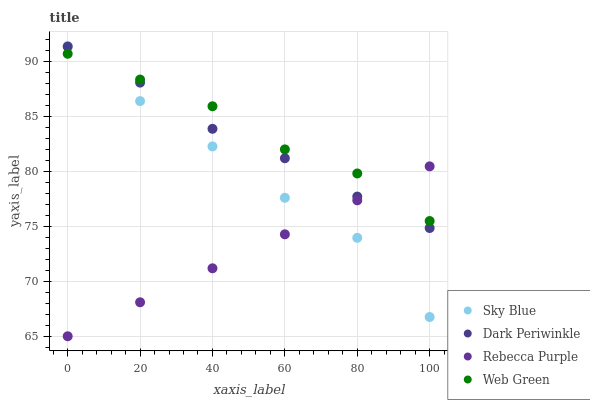Does Rebecca Purple have the minimum area under the curve?
Answer yes or no. Yes. Does Web Green have the maximum area under the curve?
Answer yes or no. Yes. Does Dark Periwinkle have the minimum area under the curve?
Answer yes or no. No. Does Dark Periwinkle have the maximum area under the curve?
Answer yes or no. No. Is Rebecca Purple the smoothest?
Answer yes or no. Yes. Is Sky Blue the roughest?
Answer yes or no. Yes. Is Dark Periwinkle the smoothest?
Answer yes or no. No. Is Dark Periwinkle the roughest?
Answer yes or no. No. Does Rebecca Purple have the lowest value?
Answer yes or no. Yes. Does Dark Periwinkle have the lowest value?
Answer yes or no. No. Does Sky Blue have the highest value?
Answer yes or no. Yes. Does Dark Periwinkle have the highest value?
Answer yes or no. No. Does Dark Periwinkle intersect Rebecca Purple?
Answer yes or no. Yes. Is Dark Periwinkle less than Rebecca Purple?
Answer yes or no. No. Is Dark Periwinkle greater than Rebecca Purple?
Answer yes or no. No. 